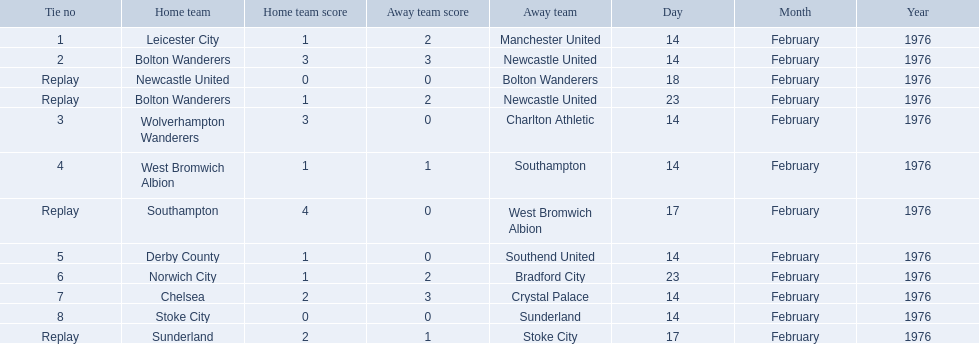Who were all of the teams? Leicester City, Manchester United, Bolton Wanderers, Newcastle United, Newcastle United, Bolton Wanderers, Bolton Wanderers, Newcastle United, Wolverhampton Wanderers, Charlton Athletic, West Bromwich Albion, Southampton, Southampton, West Bromwich Albion, Derby County, Southend United, Norwich City, Bradford City, Chelsea, Crystal Palace, Stoke City, Sunderland, Sunderland, Stoke City. And what were their scores? 1–2, 3–3, 0–0, 1–2, 3–0, 1–1, 4–0, 1–0, 1–2, 2–3, 0–0, 2–1. Between manchester and wolverhampton, who scored more? Wolverhampton Wanderers. 